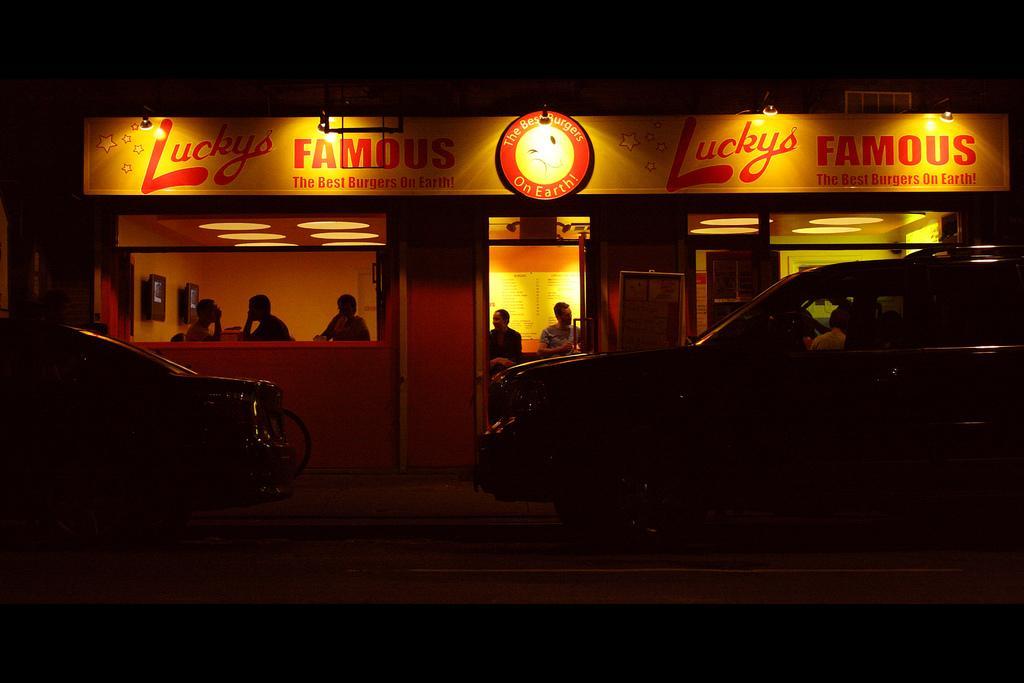Describe this image in one or two sentences. This picture is taken outside at night. Towards the left corner there is a car and towards the left corner there is a truck. In the middle there is a store, towards the door in the center there are two persons, one woman and a man. Through the window there are other three persons can be seen. 